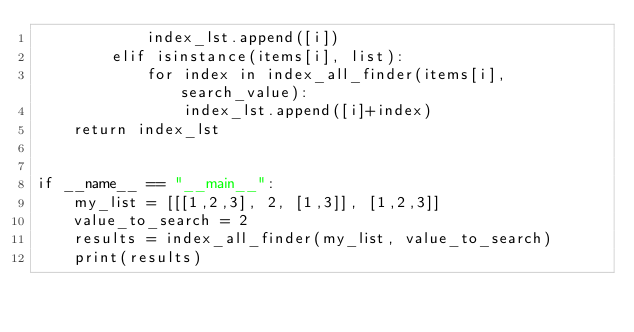<code> <loc_0><loc_0><loc_500><loc_500><_Python_>            index_lst.append([i])
        elif isinstance(items[i], list):
            for index in index_all_finder(items[i], search_value):
                index_lst.append([i]+index)
    return index_lst
    

if __name__ == "__main__":
    my_list = [[[1,2,3], 2, [1,3]], [1,2,3]]
    value_to_search = 2
    results = index_all_finder(my_list, value_to_search)
    print(results)</code> 